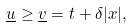<formula> <loc_0><loc_0><loc_500><loc_500>\\ \underline { u } \geq \underline { v } = t + \delta | x | , \\</formula> 